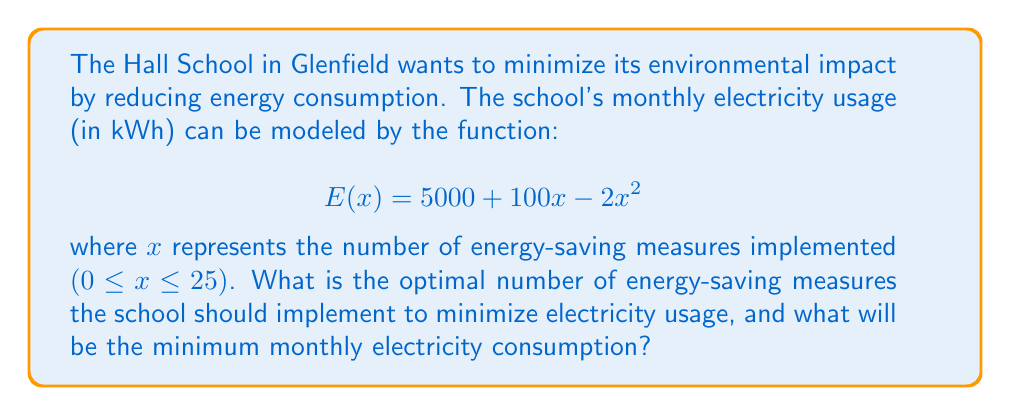Give your solution to this math problem. To find the minimum value of the electricity usage function, we need to follow these steps:

1. Find the derivative of the function $E(x)$:
   $$E'(x) = 100 - 4x$$

2. Set the derivative equal to zero and solve for x:
   $$100 - 4x = 0$$
   $$-4x = -100$$
   $$x = 25$$

3. Verify that this critical point is a minimum by checking the second derivative:
   $$E''(x) = -4$$
   Since $E''(x)$ is negative, the critical point is a local maximum.

4. Since the function is a parabola opening downward and the domain is restricted to $0 ≤ x ≤ 25$, the minimum will occur at one of the endpoints or the critical point. We need to evaluate $E(x)$ at $x = 0$, $x = 25$, and $x = 25$:

   $$E(0) = 5000 + 100(0) - 2(0)^2 = 5000$$
   $$E(25) = 5000 + 100(25) - 2(25)^2 = 5000 + 2500 - 1250 = 6250$$

5. The minimum occurs at $x = 25$, which is both the critical point and the upper bound of the domain.

6. Calculate the minimum electricity usage:
   $$E(25) = 5000 + 100(25) - 2(25)^2 = 5000 + 2500 - 1250 = 6250$$

Therefore, the optimal number of energy-saving measures is 25, and the minimum monthly electricity consumption will be 6250 kWh.
Answer: The optimal number of energy-saving measures is 25, and the minimum monthly electricity consumption will be 6250 kWh. 